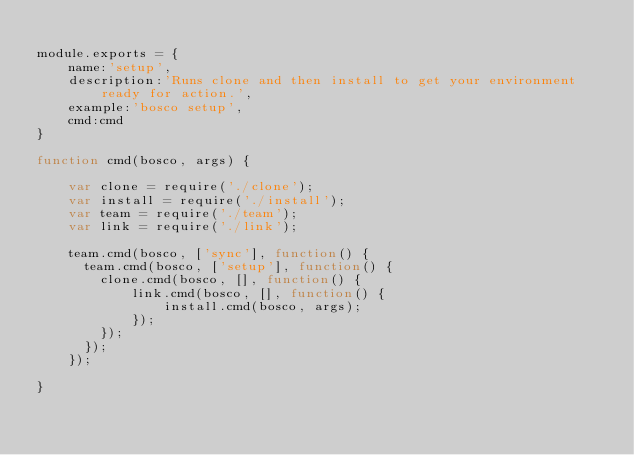Convert code to text. <code><loc_0><loc_0><loc_500><loc_500><_JavaScript_>
module.exports = {
    name:'setup',
    description:'Runs clone and then install to get your environment ready for action.',
    example:'bosco setup',
    cmd:cmd
}

function cmd(bosco, args) {

    var clone = require('./clone');
    var install = require('./install');
    var team = require('./team');
    var link = require('./link');

    team.cmd(bosco, ['sync'], function() {
      team.cmd(bosco, ['setup'], function() {
        clone.cmd(bosco, [], function() {
            link.cmd(bosco, [], function() {
                install.cmd(bosco, args);
            });
        });
      });
    });

}
</code> 